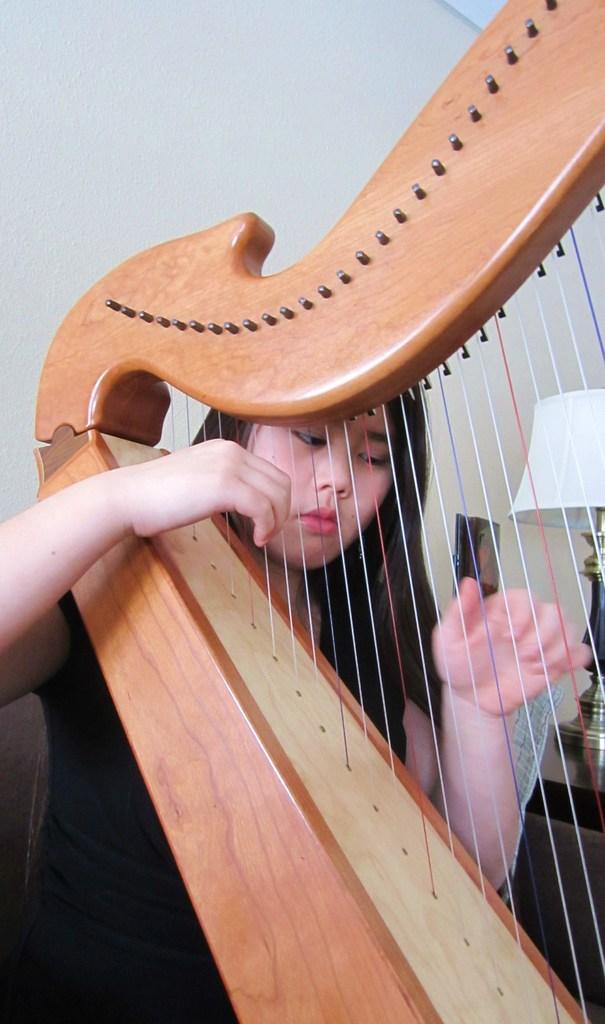Who is the main subject in the image? There is a girl in the image. What is the girl holding in the image? The girl is holding a harp. What can be seen in the background of the image? There is a wall, a lamp, and some objects in the background of the image. What type of train can be seen in the background of the image? There is no train present in the image; it features a girl holding a harp with a wall, a lamp, and other objects in the background. 